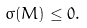<formula> <loc_0><loc_0><loc_500><loc_500>\sigma ( M ) \leq 0 .</formula> 